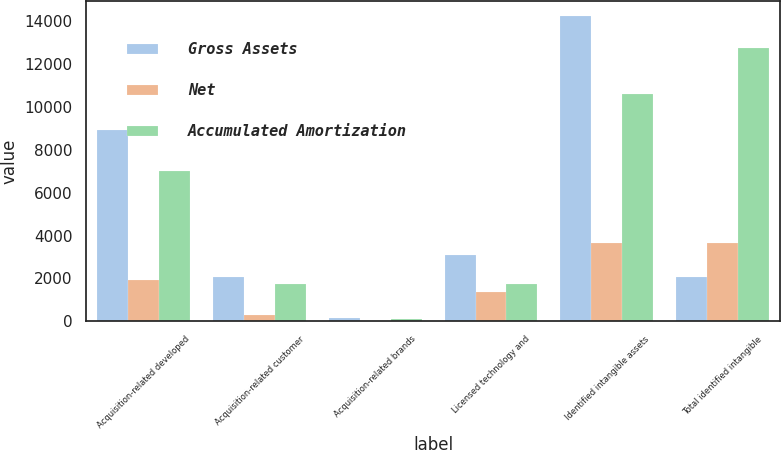<chart> <loc_0><loc_0><loc_500><loc_500><stacked_bar_chart><ecel><fcel>Acquisition-related developed<fcel>Acquisition-related customer<fcel>Acquisition-related brands<fcel>Licensed technology and<fcel>Identified intangible assets<fcel>Total identified intangible<nl><fcel>Gross Assets<fcel>8912<fcel>2052<fcel>143<fcel>3104<fcel>14211<fcel>2052<nl><fcel>Net<fcel>1922<fcel>313<fcel>29<fcel>1370<fcel>3634<fcel>3634<nl><fcel>Accumulated Amortization<fcel>6990<fcel>1739<fcel>114<fcel>1734<fcel>10577<fcel>12745<nl></chart> 